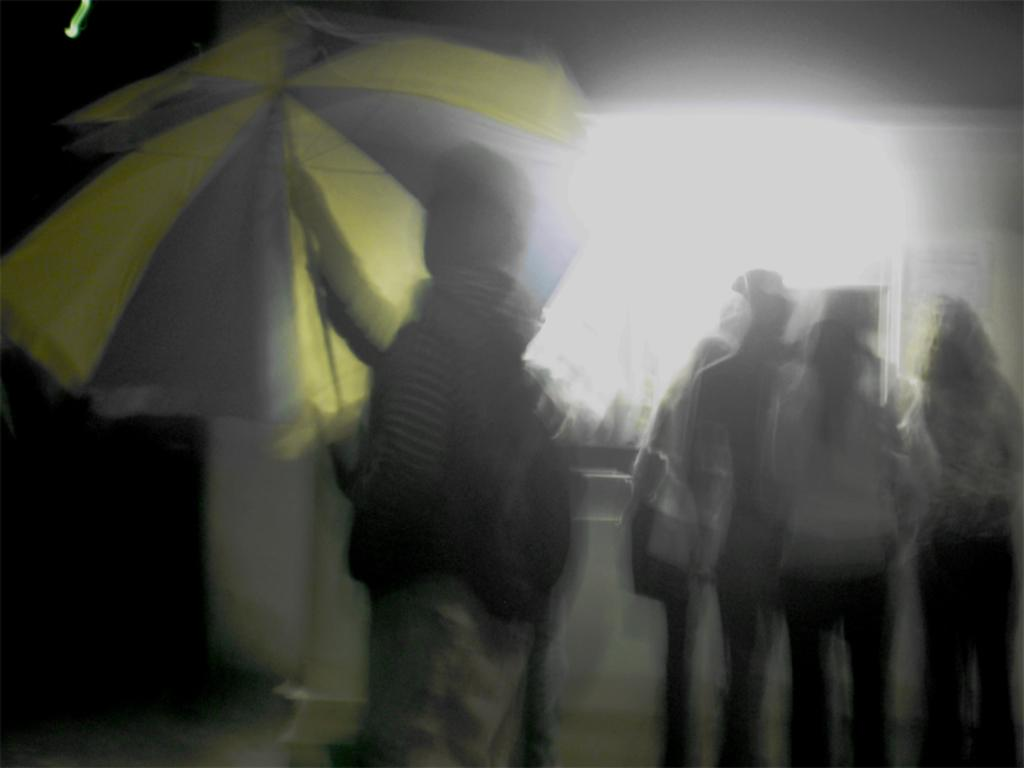How many people are in the image? There are persons in the image. Can you describe the quality of the image? The image appears to be blurred. What is the position of the person in the middle of the image? The person in the middle is holding an umbrella. What type of books can be seen being attacked by a flock of birds in the image? There are no books or birds present in the image. 